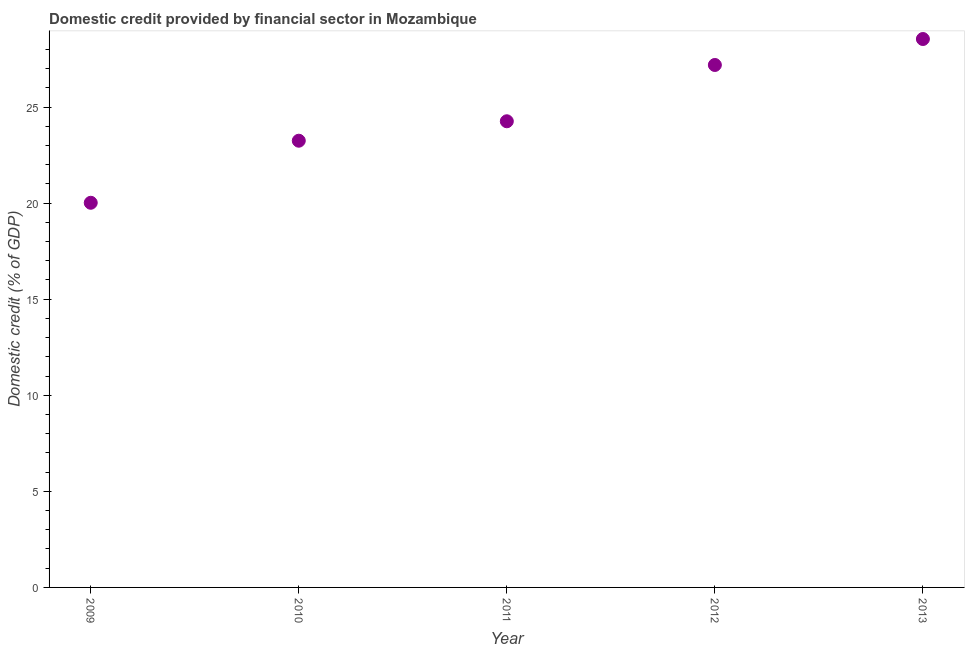What is the domestic credit provided by financial sector in 2010?
Your answer should be compact. 23.25. Across all years, what is the maximum domestic credit provided by financial sector?
Keep it short and to the point. 28.54. Across all years, what is the minimum domestic credit provided by financial sector?
Make the answer very short. 20.02. In which year was the domestic credit provided by financial sector maximum?
Your answer should be very brief. 2013. In which year was the domestic credit provided by financial sector minimum?
Provide a succinct answer. 2009. What is the sum of the domestic credit provided by financial sector?
Keep it short and to the point. 123.26. What is the difference between the domestic credit provided by financial sector in 2009 and 2012?
Keep it short and to the point. -7.17. What is the average domestic credit provided by financial sector per year?
Offer a terse response. 24.65. What is the median domestic credit provided by financial sector?
Offer a terse response. 24.26. In how many years, is the domestic credit provided by financial sector greater than 4 %?
Offer a terse response. 5. Do a majority of the years between 2009 and 2011 (inclusive) have domestic credit provided by financial sector greater than 3 %?
Your answer should be compact. Yes. What is the ratio of the domestic credit provided by financial sector in 2009 to that in 2013?
Offer a very short reply. 0.7. What is the difference between the highest and the second highest domestic credit provided by financial sector?
Provide a short and direct response. 1.35. What is the difference between the highest and the lowest domestic credit provided by financial sector?
Offer a very short reply. 8.52. How many years are there in the graph?
Provide a short and direct response. 5. Are the values on the major ticks of Y-axis written in scientific E-notation?
Keep it short and to the point. No. Does the graph contain any zero values?
Make the answer very short. No. Does the graph contain grids?
Keep it short and to the point. No. What is the title of the graph?
Your answer should be very brief. Domestic credit provided by financial sector in Mozambique. What is the label or title of the X-axis?
Give a very brief answer. Year. What is the label or title of the Y-axis?
Your response must be concise. Domestic credit (% of GDP). What is the Domestic credit (% of GDP) in 2009?
Offer a very short reply. 20.02. What is the Domestic credit (% of GDP) in 2010?
Provide a succinct answer. 23.25. What is the Domestic credit (% of GDP) in 2011?
Offer a terse response. 24.26. What is the Domestic credit (% of GDP) in 2012?
Offer a terse response. 27.19. What is the Domestic credit (% of GDP) in 2013?
Provide a short and direct response. 28.54. What is the difference between the Domestic credit (% of GDP) in 2009 and 2010?
Keep it short and to the point. -3.23. What is the difference between the Domestic credit (% of GDP) in 2009 and 2011?
Offer a terse response. -4.24. What is the difference between the Domestic credit (% of GDP) in 2009 and 2012?
Your response must be concise. -7.17. What is the difference between the Domestic credit (% of GDP) in 2009 and 2013?
Offer a very short reply. -8.52. What is the difference between the Domestic credit (% of GDP) in 2010 and 2011?
Your answer should be compact. -1.01. What is the difference between the Domestic credit (% of GDP) in 2010 and 2012?
Give a very brief answer. -3.94. What is the difference between the Domestic credit (% of GDP) in 2010 and 2013?
Give a very brief answer. -5.29. What is the difference between the Domestic credit (% of GDP) in 2011 and 2012?
Offer a terse response. -2.93. What is the difference between the Domestic credit (% of GDP) in 2011 and 2013?
Your answer should be compact. -4.28. What is the difference between the Domestic credit (% of GDP) in 2012 and 2013?
Provide a short and direct response. -1.35. What is the ratio of the Domestic credit (% of GDP) in 2009 to that in 2010?
Ensure brevity in your answer.  0.86. What is the ratio of the Domestic credit (% of GDP) in 2009 to that in 2011?
Ensure brevity in your answer.  0.82. What is the ratio of the Domestic credit (% of GDP) in 2009 to that in 2012?
Provide a short and direct response. 0.74. What is the ratio of the Domestic credit (% of GDP) in 2009 to that in 2013?
Offer a terse response. 0.7. What is the ratio of the Domestic credit (% of GDP) in 2010 to that in 2011?
Your answer should be very brief. 0.96. What is the ratio of the Domestic credit (% of GDP) in 2010 to that in 2012?
Give a very brief answer. 0.85. What is the ratio of the Domestic credit (% of GDP) in 2010 to that in 2013?
Your answer should be very brief. 0.81. What is the ratio of the Domestic credit (% of GDP) in 2011 to that in 2012?
Offer a very short reply. 0.89. What is the ratio of the Domestic credit (% of GDP) in 2012 to that in 2013?
Your response must be concise. 0.95. 